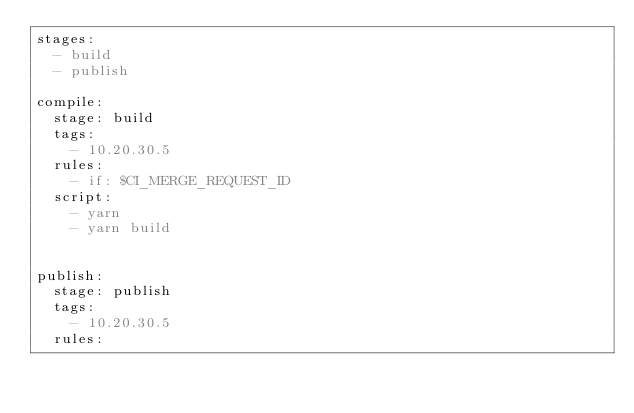Convert code to text. <code><loc_0><loc_0><loc_500><loc_500><_YAML_>stages:
  - build
  - publish

compile:
  stage: build
  tags:
    - 10.20.30.5
  rules:
    - if: $CI_MERGE_REQUEST_ID
  script:
    - yarn
    - yarn build


publish:
  stage: publish
  tags:
    - 10.20.30.5
  rules:</code> 